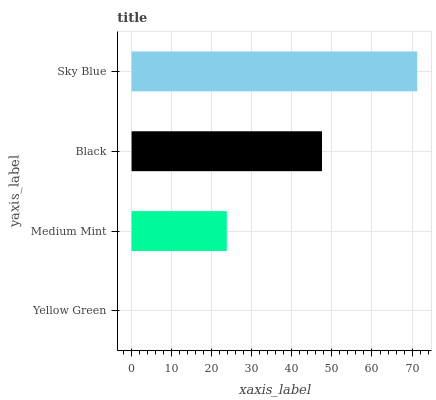Is Yellow Green the minimum?
Answer yes or no. Yes. Is Sky Blue the maximum?
Answer yes or no. Yes. Is Medium Mint the minimum?
Answer yes or no. No. Is Medium Mint the maximum?
Answer yes or no. No. Is Medium Mint greater than Yellow Green?
Answer yes or no. Yes. Is Yellow Green less than Medium Mint?
Answer yes or no. Yes. Is Yellow Green greater than Medium Mint?
Answer yes or no. No. Is Medium Mint less than Yellow Green?
Answer yes or no. No. Is Black the high median?
Answer yes or no. Yes. Is Medium Mint the low median?
Answer yes or no. Yes. Is Sky Blue the high median?
Answer yes or no. No. Is Sky Blue the low median?
Answer yes or no. No. 